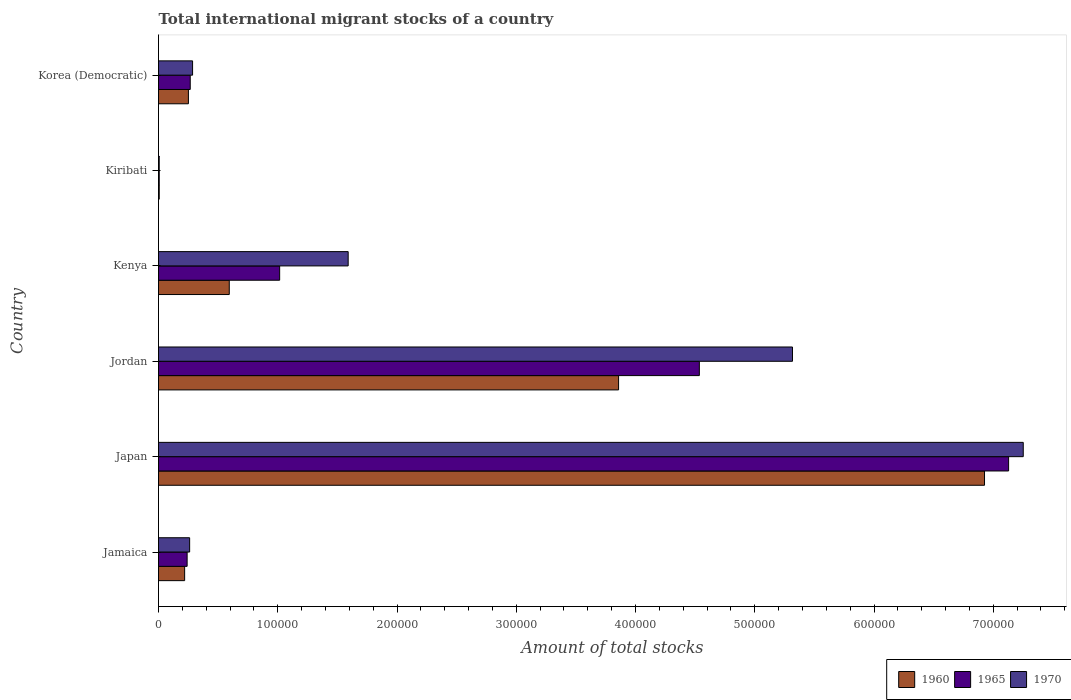Are the number of bars on each tick of the Y-axis equal?
Give a very brief answer. Yes. How many bars are there on the 3rd tick from the bottom?
Offer a very short reply. 3. What is the label of the 4th group of bars from the top?
Your answer should be very brief. Jordan. What is the amount of total stocks in in 1970 in Jordan?
Provide a succinct answer. 5.32e+05. Across all countries, what is the maximum amount of total stocks in in 1965?
Your response must be concise. 7.13e+05. Across all countries, what is the minimum amount of total stocks in in 1970?
Your answer should be very brief. 587. In which country was the amount of total stocks in in 1960 minimum?
Provide a succinct answer. Kiribati. What is the total amount of total stocks in in 1970 in the graph?
Your response must be concise. 1.47e+06. What is the difference between the amount of total stocks in in 1970 in Jamaica and that in Jordan?
Offer a very short reply. -5.06e+05. What is the difference between the amount of total stocks in in 1960 in Kiribati and the amount of total stocks in in 1965 in Jamaica?
Provide a short and direct response. -2.34e+04. What is the average amount of total stocks in in 1965 per country?
Make the answer very short. 2.20e+05. What is the difference between the amount of total stocks in in 1965 and amount of total stocks in in 1960 in Jordan?
Your response must be concise. 6.77e+04. What is the ratio of the amount of total stocks in in 1960 in Jamaica to that in Jordan?
Provide a succinct answer. 0.06. Is the difference between the amount of total stocks in in 1965 in Jamaica and Korea (Democratic) greater than the difference between the amount of total stocks in in 1960 in Jamaica and Korea (Democratic)?
Your answer should be compact. Yes. What is the difference between the highest and the second highest amount of total stocks in in 1960?
Ensure brevity in your answer.  3.07e+05. What is the difference between the highest and the lowest amount of total stocks in in 1960?
Provide a short and direct response. 6.92e+05. In how many countries, is the amount of total stocks in in 1970 greater than the average amount of total stocks in in 1970 taken over all countries?
Your response must be concise. 2. Is the sum of the amount of total stocks in in 1970 in Kiribati and Korea (Democratic) greater than the maximum amount of total stocks in in 1960 across all countries?
Ensure brevity in your answer.  No. What does the 3rd bar from the bottom in Korea (Democratic) represents?
Offer a very short reply. 1970. How many countries are there in the graph?
Your answer should be very brief. 6. Are the values on the major ticks of X-axis written in scientific E-notation?
Keep it short and to the point. No. Does the graph contain any zero values?
Your response must be concise. No. How many legend labels are there?
Your answer should be compact. 3. What is the title of the graph?
Give a very brief answer. Total international migrant stocks of a country. Does "1966" appear as one of the legend labels in the graph?
Your response must be concise. No. What is the label or title of the X-axis?
Make the answer very short. Amount of total stocks. What is the label or title of the Y-axis?
Provide a succinct answer. Country. What is the Amount of total stocks of 1960 in Jamaica?
Keep it short and to the point. 2.19e+04. What is the Amount of total stocks in 1965 in Jamaica?
Ensure brevity in your answer.  2.40e+04. What is the Amount of total stocks in 1970 in Jamaica?
Your answer should be very brief. 2.61e+04. What is the Amount of total stocks of 1960 in Japan?
Your answer should be compact. 6.93e+05. What is the Amount of total stocks of 1965 in Japan?
Your answer should be compact. 7.13e+05. What is the Amount of total stocks of 1970 in Japan?
Keep it short and to the point. 7.25e+05. What is the Amount of total stocks of 1960 in Jordan?
Your response must be concise. 3.86e+05. What is the Amount of total stocks in 1965 in Jordan?
Provide a short and direct response. 4.54e+05. What is the Amount of total stocks of 1970 in Jordan?
Give a very brief answer. 5.32e+05. What is the Amount of total stocks of 1960 in Kenya?
Ensure brevity in your answer.  5.93e+04. What is the Amount of total stocks in 1965 in Kenya?
Your response must be concise. 1.02e+05. What is the Amount of total stocks of 1970 in Kenya?
Give a very brief answer. 1.59e+05. What is the Amount of total stocks of 1960 in Kiribati?
Keep it short and to the point. 610. What is the Amount of total stocks of 1965 in Kiribati?
Your response must be concise. 602. What is the Amount of total stocks of 1970 in Kiribati?
Offer a very short reply. 587. What is the Amount of total stocks of 1960 in Korea (Democratic)?
Your response must be concise. 2.51e+04. What is the Amount of total stocks of 1965 in Korea (Democratic)?
Make the answer very short. 2.66e+04. What is the Amount of total stocks of 1970 in Korea (Democratic)?
Provide a succinct answer. 2.86e+04. Across all countries, what is the maximum Amount of total stocks in 1960?
Offer a very short reply. 6.93e+05. Across all countries, what is the maximum Amount of total stocks of 1965?
Give a very brief answer. 7.13e+05. Across all countries, what is the maximum Amount of total stocks in 1970?
Ensure brevity in your answer.  7.25e+05. Across all countries, what is the minimum Amount of total stocks in 1960?
Keep it short and to the point. 610. Across all countries, what is the minimum Amount of total stocks in 1965?
Keep it short and to the point. 602. Across all countries, what is the minimum Amount of total stocks of 1970?
Provide a short and direct response. 587. What is the total Amount of total stocks of 1960 in the graph?
Keep it short and to the point. 1.19e+06. What is the total Amount of total stocks of 1965 in the graph?
Make the answer very short. 1.32e+06. What is the total Amount of total stocks in 1970 in the graph?
Provide a succinct answer. 1.47e+06. What is the difference between the Amount of total stocks in 1960 in Jamaica and that in Japan?
Give a very brief answer. -6.71e+05. What is the difference between the Amount of total stocks in 1965 in Jamaica and that in Japan?
Keep it short and to the point. -6.89e+05. What is the difference between the Amount of total stocks of 1970 in Jamaica and that in Japan?
Your answer should be compact. -6.99e+05. What is the difference between the Amount of total stocks of 1960 in Jamaica and that in Jordan?
Keep it short and to the point. -3.64e+05. What is the difference between the Amount of total stocks of 1965 in Jamaica and that in Jordan?
Ensure brevity in your answer.  -4.30e+05. What is the difference between the Amount of total stocks of 1970 in Jamaica and that in Jordan?
Your answer should be compact. -5.06e+05. What is the difference between the Amount of total stocks of 1960 in Jamaica and that in Kenya?
Your answer should be very brief. -3.74e+04. What is the difference between the Amount of total stocks in 1965 in Jamaica and that in Kenya?
Make the answer very short. -7.76e+04. What is the difference between the Amount of total stocks in 1970 in Jamaica and that in Kenya?
Keep it short and to the point. -1.33e+05. What is the difference between the Amount of total stocks of 1960 in Jamaica and that in Kiribati?
Give a very brief answer. 2.13e+04. What is the difference between the Amount of total stocks of 1965 in Jamaica and that in Kiribati?
Ensure brevity in your answer.  2.34e+04. What is the difference between the Amount of total stocks of 1970 in Jamaica and that in Kiribati?
Offer a terse response. 2.55e+04. What is the difference between the Amount of total stocks in 1960 in Jamaica and that in Korea (Democratic)?
Provide a succinct answer. -3168. What is the difference between the Amount of total stocks in 1965 in Jamaica and that in Korea (Democratic)?
Your answer should be very brief. -2602. What is the difference between the Amount of total stocks of 1970 in Jamaica and that in Korea (Democratic)?
Keep it short and to the point. -2468. What is the difference between the Amount of total stocks of 1960 in Japan and that in Jordan?
Keep it short and to the point. 3.07e+05. What is the difference between the Amount of total stocks in 1965 in Japan and that in Jordan?
Keep it short and to the point. 2.59e+05. What is the difference between the Amount of total stocks in 1970 in Japan and that in Jordan?
Give a very brief answer. 1.94e+05. What is the difference between the Amount of total stocks in 1960 in Japan and that in Kenya?
Offer a terse response. 6.33e+05. What is the difference between the Amount of total stocks of 1965 in Japan and that in Kenya?
Your response must be concise. 6.11e+05. What is the difference between the Amount of total stocks of 1970 in Japan and that in Kenya?
Make the answer very short. 5.66e+05. What is the difference between the Amount of total stocks of 1960 in Japan and that in Kiribati?
Offer a very short reply. 6.92e+05. What is the difference between the Amount of total stocks in 1965 in Japan and that in Kiribati?
Provide a short and direct response. 7.12e+05. What is the difference between the Amount of total stocks in 1970 in Japan and that in Kiribati?
Offer a terse response. 7.25e+05. What is the difference between the Amount of total stocks of 1960 in Japan and that in Korea (Democratic)?
Make the answer very short. 6.68e+05. What is the difference between the Amount of total stocks in 1965 in Japan and that in Korea (Democratic)?
Your answer should be very brief. 6.86e+05. What is the difference between the Amount of total stocks in 1970 in Japan and that in Korea (Democratic)?
Offer a terse response. 6.97e+05. What is the difference between the Amount of total stocks in 1960 in Jordan and that in Kenya?
Your answer should be compact. 3.26e+05. What is the difference between the Amount of total stocks in 1965 in Jordan and that in Kenya?
Your answer should be compact. 3.52e+05. What is the difference between the Amount of total stocks in 1970 in Jordan and that in Kenya?
Offer a very short reply. 3.73e+05. What is the difference between the Amount of total stocks in 1960 in Jordan and that in Kiribati?
Your response must be concise. 3.85e+05. What is the difference between the Amount of total stocks of 1965 in Jordan and that in Kiribati?
Make the answer very short. 4.53e+05. What is the difference between the Amount of total stocks in 1970 in Jordan and that in Kiribati?
Make the answer very short. 5.31e+05. What is the difference between the Amount of total stocks in 1960 in Jordan and that in Korea (Democratic)?
Give a very brief answer. 3.61e+05. What is the difference between the Amount of total stocks in 1965 in Jordan and that in Korea (Democratic)?
Make the answer very short. 4.27e+05. What is the difference between the Amount of total stocks of 1970 in Jordan and that in Korea (Democratic)?
Your response must be concise. 5.03e+05. What is the difference between the Amount of total stocks in 1960 in Kenya and that in Kiribati?
Provide a short and direct response. 5.87e+04. What is the difference between the Amount of total stocks of 1965 in Kenya and that in Kiribati?
Give a very brief answer. 1.01e+05. What is the difference between the Amount of total stocks of 1970 in Kenya and that in Kiribati?
Make the answer very short. 1.58e+05. What is the difference between the Amount of total stocks in 1960 in Kenya and that in Korea (Democratic)?
Give a very brief answer. 3.43e+04. What is the difference between the Amount of total stocks of 1965 in Kenya and that in Korea (Democratic)?
Make the answer very short. 7.50e+04. What is the difference between the Amount of total stocks of 1970 in Kenya and that in Korea (Democratic)?
Offer a terse response. 1.30e+05. What is the difference between the Amount of total stocks of 1960 in Kiribati and that in Korea (Democratic)?
Your response must be concise. -2.45e+04. What is the difference between the Amount of total stocks of 1965 in Kiribati and that in Korea (Democratic)?
Keep it short and to the point. -2.60e+04. What is the difference between the Amount of total stocks of 1970 in Kiribati and that in Korea (Democratic)?
Offer a very short reply. -2.80e+04. What is the difference between the Amount of total stocks in 1960 in Jamaica and the Amount of total stocks in 1965 in Japan?
Make the answer very short. -6.91e+05. What is the difference between the Amount of total stocks in 1960 in Jamaica and the Amount of total stocks in 1970 in Japan?
Provide a short and direct response. -7.03e+05. What is the difference between the Amount of total stocks of 1965 in Jamaica and the Amount of total stocks of 1970 in Japan?
Keep it short and to the point. -7.01e+05. What is the difference between the Amount of total stocks of 1960 in Jamaica and the Amount of total stocks of 1965 in Jordan?
Give a very brief answer. -4.32e+05. What is the difference between the Amount of total stocks of 1960 in Jamaica and the Amount of total stocks of 1970 in Jordan?
Make the answer very short. -5.10e+05. What is the difference between the Amount of total stocks of 1965 in Jamaica and the Amount of total stocks of 1970 in Jordan?
Make the answer very short. -5.08e+05. What is the difference between the Amount of total stocks in 1960 in Jamaica and the Amount of total stocks in 1965 in Kenya?
Provide a short and direct response. -7.97e+04. What is the difference between the Amount of total stocks in 1960 in Jamaica and the Amount of total stocks in 1970 in Kenya?
Offer a terse response. -1.37e+05. What is the difference between the Amount of total stocks of 1965 in Jamaica and the Amount of total stocks of 1970 in Kenya?
Ensure brevity in your answer.  -1.35e+05. What is the difference between the Amount of total stocks of 1960 in Jamaica and the Amount of total stocks of 1965 in Kiribati?
Ensure brevity in your answer.  2.13e+04. What is the difference between the Amount of total stocks of 1960 in Jamaica and the Amount of total stocks of 1970 in Kiribati?
Make the answer very short. 2.13e+04. What is the difference between the Amount of total stocks of 1965 in Jamaica and the Amount of total stocks of 1970 in Kiribati?
Your response must be concise. 2.34e+04. What is the difference between the Amount of total stocks of 1960 in Jamaica and the Amount of total stocks of 1965 in Korea (Democratic)?
Your response must be concise. -4692. What is the difference between the Amount of total stocks of 1960 in Jamaica and the Amount of total stocks of 1970 in Korea (Democratic)?
Provide a succinct answer. -6664. What is the difference between the Amount of total stocks of 1965 in Jamaica and the Amount of total stocks of 1970 in Korea (Democratic)?
Offer a terse response. -4574. What is the difference between the Amount of total stocks of 1960 in Japan and the Amount of total stocks of 1965 in Jordan?
Your answer should be compact. 2.39e+05. What is the difference between the Amount of total stocks in 1960 in Japan and the Amount of total stocks in 1970 in Jordan?
Your answer should be compact. 1.61e+05. What is the difference between the Amount of total stocks of 1965 in Japan and the Amount of total stocks of 1970 in Jordan?
Make the answer very short. 1.81e+05. What is the difference between the Amount of total stocks in 1960 in Japan and the Amount of total stocks in 1965 in Kenya?
Ensure brevity in your answer.  5.91e+05. What is the difference between the Amount of total stocks of 1960 in Japan and the Amount of total stocks of 1970 in Kenya?
Your answer should be very brief. 5.34e+05. What is the difference between the Amount of total stocks in 1965 in Japan and the Amount of total stocks in 1970 in Kenya?
Offer a very short reply. 5.54e+05. What is the difference between the Amount of total stocks of 1960 in Japan and the Amount of total stocks of 1965 in Kiribati?
Your response must be concise. 6.92e+05. What is the difference between the Amount of total stocks of 1960 in Japan and the Amount of total stocks of 1970 in Kiribati?
Offer a terse response. 6.92e+05. What is the difference between the Amount of total stocks of 1965 in Japan and the Amount of total stocks of 1970 in Kiribati?
Your answer should be very brief. 7.12e+05. What is the difference between the Amount of total stocks in 1960 in Japan and the Amount of total stocks in 1965 in Korea (Democratic)?
Offer a very short reply. 6.66e+05. What is the difference between the Amount of total stocks of 1960 in Japan and the Amount of total stocks of 1970 in Korea (Democratic)?
Make the answer very short. 6.64e+05. What is the difference between the Amount of total stocks of 1965 in Japan and the Amount of total stocks of 1970 in Korea (Democratic)?
Your response must be concise. 6.84e+05. What is the difference between the Amount of total stocks in 1960 in Jordan and the Amount of total stocks in 1965 in Kenya?
Provide a short and direct response. 2.84e+05. What is the difference between the Amount of total stocks of 1960 in Jordan and the Amount of total stocks of 1970 in Kenya?
Your answer should be very brief. 2.27e+05. What is the difference between the Amount of total stocks of 1965 in Jordan and the Amount of total stocks of 1970 in Kenya?
Provide a short and direct response. 2.94e+05. What is the difference between the Amount of total stocks of 1960 in Jordan and the Amount of total stocks of 1965 in Kiribati?
Give a very brief answer. 3.85e+05. What is the difference between the Amount of total stocks in 1960 in Jordan and the Amount of total stocks in 1970 in Kiribati?
Your answer should be compact. 3.85e+05. What is the difference between the Amount of total stocks in 1965 in Jordan and the Amount of total stocks in 1970 in Kiribati?
Provide a succinct answer. 4.53e+05. What is the difference between the Amount of total stocks in 1960 in Jordan and the Amount of total stocks in 1965 in Korea (Democratic)?
Ensure brevity in your answer.  3.59e+05. What is the difference between the Amount of total stocks of 1960 in Jordan and the Amount of total stocks of 1970 in Korea (Democratic)?
Provide a succinct answer. 3.57e+05. What is the difference between the Amount of total stocks of 1965 in Jordan and the Amount of total stocks of 1970 in Korea (Democratic)?
Provide a succinct answer. 4.25e+05. What is the difference between the Amount of total stocks of 1960 in Kenya and the Amount of total stocks of 1965 in Kiribati?
Give a very brief answer. 5.87e+04. What is the difference between the Amount of total stocks in 1960 in Kenya and the Amount of total stocks in 1970 in Kiribati?
Make the answer very short. 5.87e+04. What is the difference between the Amount of total stocks of 1965 in Kenya and the Amount of total stocks of 1970 in Kiribati?
Provide a short and direct response. 1.01e+05. What is the difference between the Amount of total stocks in 1960 in Kenya and the Amount of total stocks in 1965 in Korea (Democratic)?
Give a very brief answer. 3.27e+04. What is the difference between the Amount of total stocks of 1960 in Kenya and the Amount of total stocks of 1970 in Korea (Democratic)?
Keep it short and to the point. 3.08e+04. What is the difference between the Amount of total stocks of 1965 in Kenya and the Amount of total stocks of 1970 in Korea (Democratic)?
Provide a succinct answer. 7.30e+04. What is the difference between the Amount of total stocks of 1960 in Kiribati and the Amount of total stocks of 1965 in Korea (Democratic)?
Offer a terse response. -2.60e+04. What is the difference between the Amount of total stocks in 1960 in Kiribati and the Amount of total stocks in 1970 in Korea (Democratic)?
Ensure brevity in your answer.  -2.80e+04. What is the difference between the Amount of total stocks of 1965 in Kiribati and the Amount of total stocks of 1970 in Korea (Democratic)?
Your answer should be compact. -2.80e+04. What is the average Amount of total stocks of 1960 per country?
Your answer should be very brief. 1.98e+05. What is the average Amount of total stocks of 1965 per country?
Provide a short and direct response. 2.20e+05. What is the average Amount of total stocks of 1970 per country?
Provide a succinct answer. 2.45e+05. What is the difference between the Amount of total stocks in 1960 and Amount of total stocks in 1965 in Jamaica?
Ensure brevity in your answer.  -2090. What is the difference between the Amount of total stocks of 1960 and Amount of total stocks of 1970 in Jamaica?
Provide a succinct answer. -4196. What is the difference between the Amount of total stocks in 1965 and Amount of total stocks in 1970 in Jamaica?
Provide a short and direct response. -2106. What is the difference between the Amount of total stocks of 1960 and Amount of total stocks of 1965 in Japan?
Ensure brevity in your answer.  -2.02e+04. What is the difference between the Amount of total stocks in 1960 and Amount of total stocks in 1970 in Japan?
Keep it short and to the point. -3.25e+04. What is the difference between the Amount of total stocks of 1965 and Amount of total stocks of 1970 in Japan?
Make the answer very short. -1.23e+04. What is the difference between the Amount of total stocks of 1960 and Amount of total stocks of 1965 in Jordan?
Give a very brief answer. -6.77e+04. What is the difference between the Amount of total stocks of 1960 and Amount of total stocks of 1970 in Jordan?
Make the answer very short. -1.46e+05. What is the difference between the Amount of total stocks in 1965 and Amount of total stocks in 1970 in Jordan?
Provide a succinct answer. -7.81e+04. What is the difference between the Amount of total stocks in 1960 and Amount of total stocks in 1965 in Kenya?
Provide a short and direct response. -4.23e+04. What is the difference between the Amount of total stocks of 1960 and Amount of total stocks of 1970 in Kenya?
Provide a succinct answer. -9.97e+04. What is the difference between the Amount of total stocks in 1965 and Amount of total stocks in 1970 in Kenya?
Your answer should be very brief. -5.75e+04. What is the difference between the Amount of total stocks in 1960 and Amount of total stocks in 1965 in Korea (Democratic)?
Your answer should be compact. -1524. What is the difference between the Amount of total stocks of 1960 and Amount of total stocks of 1970 in Korea (Democratic)?
Ensure brevity in your answer.  -3496. What is the difference between the Amount of total stocks in 1965 and Amount of total stocks in 1970 in Korea (Democratic)?
Ensure brevity in your answer.  -1972. What is the ratio of the Amount of total stocks in 1960 in Jamaica to that in Japan?
Offer a terse response. 0.03. What is the ratio of the Amount of total stocks of 1965 in Jamaica to that in Japan?
Offer a very short reply. 0.03. What is the ratio of the Amount of total stocks of 1970 in Jamaica to that in Japan?
Your answer should be compact. 0.04. What is the ratio of the Amount of total stocks of 1960 in Jamaica to that in Jordan?
Offer a very short reply. 0.06. What is the ratio of the Amount of total stocks of 1965 in Jamaica to that in Jordan?
Offer a terse response. 0.05. What is the ratio of the Amount of total stocks in 1970 in Jamaica to that in Jordan?
Provide a short and direct response. 0.05. What is the ratio of the Amount of total stocks of 1960 in Jamaica to that in Kenya?
Offer a terse response. 0.37. What is the ratio of the Amount of total stocks in 1965 in Jamaica to that in Kenya?
Ensure brevity in your answer.  0.24. What is the ratio of the Amount of total stocks in 1970 in Jamaica to that in Kenya?
Your answer should be very brief. 0.16. What is the ratio of the Amount of total stocks in 1960 in Jamaica to that in Kiribati?
Your response must be concise. 35.91. What is the ratio of the Amount of total stocks in 1965 in Jamaica to that in Kiribati?
Provide a succinct answer. 39.86. What is the ratio of the Amount of total stocks of 1970 in Jamaica to that in Kiribati?
Ensure brevity in your answer.  44.46. What is the ratio of the Amount of total stocks in 1960 in Jamaica to that in Korea (Democratic)?
Ensure brevity in your answer.  0.87. What is the ratio of the Amount of total stocks in 1965 in Jamaica to that in Korea (Democratic)?
Offer a terse response. 0.9. What is the ratio of the Amount of total stocks of 1970 in Jamaica to that in Korea (Democratic)?
Make the answer very short. 0.91. What is the ratio of the Amount of total stocks in 1960 in Japan to that in Jordan?
Keep it short and to the point. 1.8. What is the ratio of the Amount of total stocks in 1965 in Japan to that in Jordan?
Your answer should be compact. 1.57. What is the ratio of the Amount of total stocks in 1970 in Japan to that in Jordan?
Your answer should be compact. 1.36. What is the ratio of the Amount of total stocks in 1960 in Japan to that in Kenya?
Make the answer very short. 11.67. What is the ratio of the Amount of total stocks of 1965 in Japan to that in Kenya?
Offer a very short reply. 7.02. What is the ratio of the Amount of total stocks in 1970 in Japan to that in Kenya?
Provide a succinct answer. 4.56. What is the ratio of the Amount of total stocks of 1960 in Japan to that in Kiribati?
Your answer should be very brief. 1135.49. What is the ratio of the Amount of total stocks of 1965 in Japan to that in Kiribati?
Your response must be concise. 1184.14. What is the ratio of the Amount of total stocks of 1970 in Japan to that in Kiribati?
Offer a very short reply. 1235.33. What is the ratio of the Amount of total stocks of 1960 in Japan to that in Korea (Democratic)?
Your answer should be very brief. 27.63. What is the ratio of the Amount of total stocks of 1965 in Japan to that in Korea (Democratic)?
Your response must be concise. 26.8. What is the ratio of the Amount of total stocks in 1970 in Japan to that in Korea (Democratic)?
Keep it short and to the point. 25.38. What is the ratio of the Amount of total stocks in 1960 in Jordan to that in Kenya?
Ensure brevity in your answer.  6.5. What is the ratio of the Amount of total stocks of 1965 in Jordan to that in Kenya?
Your response must be concise. 4.46. What is the ratio of the Amount of total stocks of 1970 in Jordan to that in Kenya?
Your answer should be compact. 3.34. What is the ratio of the Amount of total stocks in 1960 in Jordan to that in Kiribati?
Give a very brief answer. 632.44. What is the ratio of the Amount of total stocks in 1965 in Jordan to that in Kiribati?
Provide a short and direct response. 753.36. What is the ratio of the Amount of total stocks in 1970 in Jordan to that in Kiribati?
Make the answer very short. 905.65. What is the ratio of the Amount of total stocks of 1960 in Jordan to that in Korea (Democratic)?
Provide a short and direct response. 15.39. What is the ratio of the Amount of total stocks in 1965 in Jordan to that in Korea (Democratic)?
Provide a succinct answer. 17.05. What is the ratio of the Amount of total stocks in 1970 in Jordan to that in Korea (Democratic)?
Make the answer very short. 18.61. What is the ratio of the Amount of total stocks in 1960 in Kenya to that in Kiribati?
Make the answer very short. 97.26. What is the ratio of the Amount of total stocks in 1965 in Kenya to that in Kiribati?
Ensure brevity in your answer.  168.74. What is the ratio of the Amount of total stocks of 1970 in Kenya to that in Kiribati?
Provide a succinct answer. 270.94. What is the ratio of the Amount of total stocks in 1960 in Kenya to that in Korea (Democratic)?
Your answer should be compact. 2.37. What is the ratio of the Amount of total stocks in 1965 in Kenya to that in Korea (Democratic)?
Your answer should be very brief. 3.82. What is the ratio of the Amount of total stocks of 1970 in Kenya to that in Korea (Democratic)?
Your response must be concise. 5.57. What is the ratio of the Amount of total stocks in 1960 in Kiribati to that in Korea (Democratic)?
Ensure brevity in your answer.  0.02. What is the ratio of the Amount of total stocks in 1965 in Kiribati to that in Korea (Democratic)?
Provide a succinct answer. 0.02. What is the ratio of the Amount of total stocks in 1970 in Kiribati to that in Korea (Democratic)?
Keep it short and to the point. 0.02. What is the difference between the highest and the second highest Amount of total stocks in 1960?
Your response must be concise. 3.07e+05. What is the difference between the highest and the second highest Amount of total stocks of 1965?
Provide a short and direct response. 2.59e+05. What is the difference between the highest and the second highest Amount of total stocks in 1970?
Your response must be concise. 1.94e+05. What is the difference between the highest and the lowest Amount of total stocks in 1960?
Keep it short and to the point. 6.92e+05. What is the difference between the highest and the lowest Amount of total stocks of 1965?
Offer a terse response. 7.12e+05. What is the difference between the highest and the lowest Amount of total stocks of 1970?
Make the answer very short. 7.25e+05. 